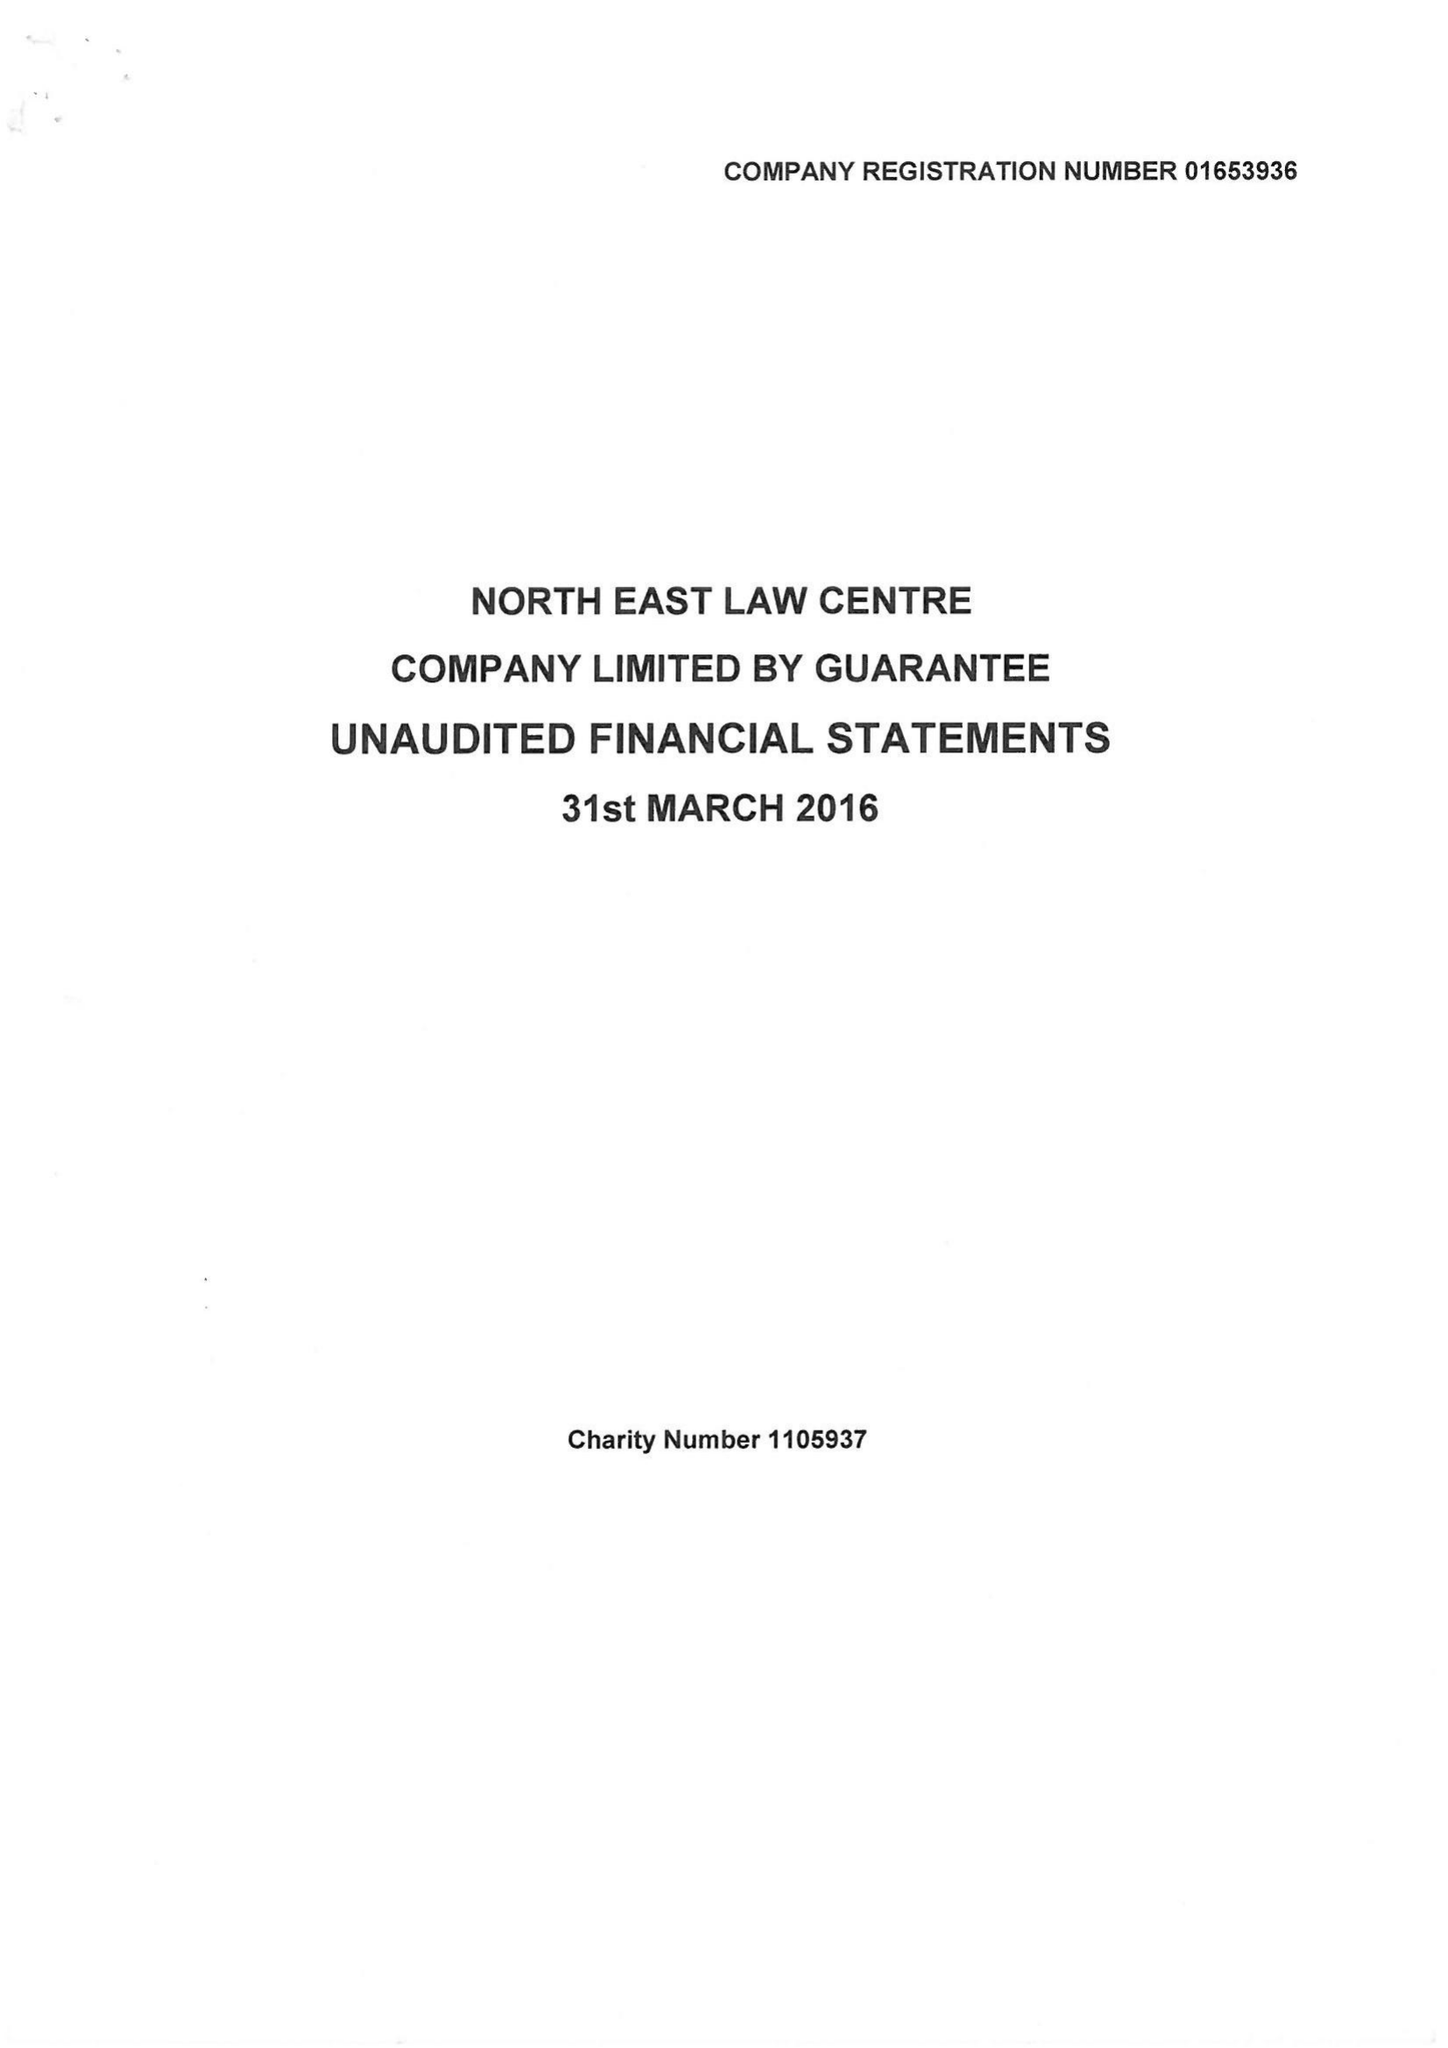What is the value for the spending_annually_in_british_pounds?
Answer the question using a single word or phrase. 222069.00 